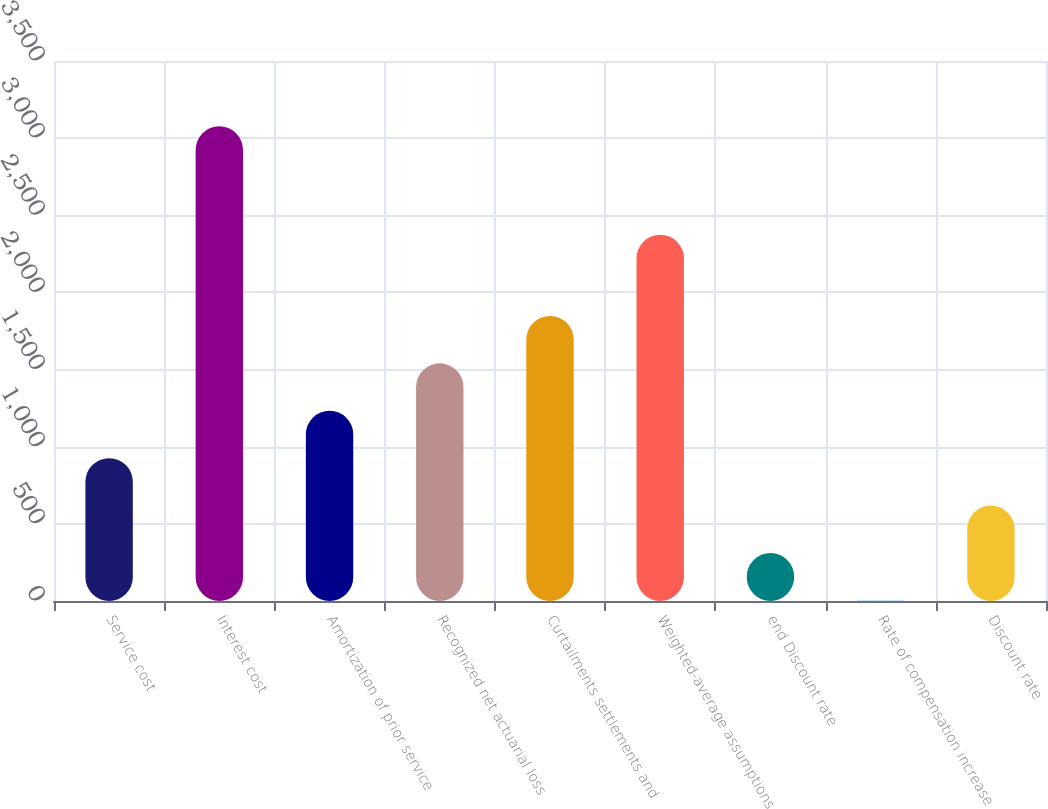Convert chart to OTSL. <chart><loc_0><loc_0><loc_500><loc_500><bar_chart><fcel>Service cost<fcel>Interest cost<fcel>Amortization of prior service<fcel>Recognized net actuarial loss<fcel>Curtailments settlements and<fcel>Weighted-average assumptions<fcel>end Discount rate<fcel>Rate of compensation increase<fcel>Discount rate<nl><fcel>925.87<fcel>3077<fcel>1233.18<fcel>1540.49<fcel>1847.8<fcel>2374<fcel>311.25<fcel>3.94<fcel>618.56<nl></chart> 